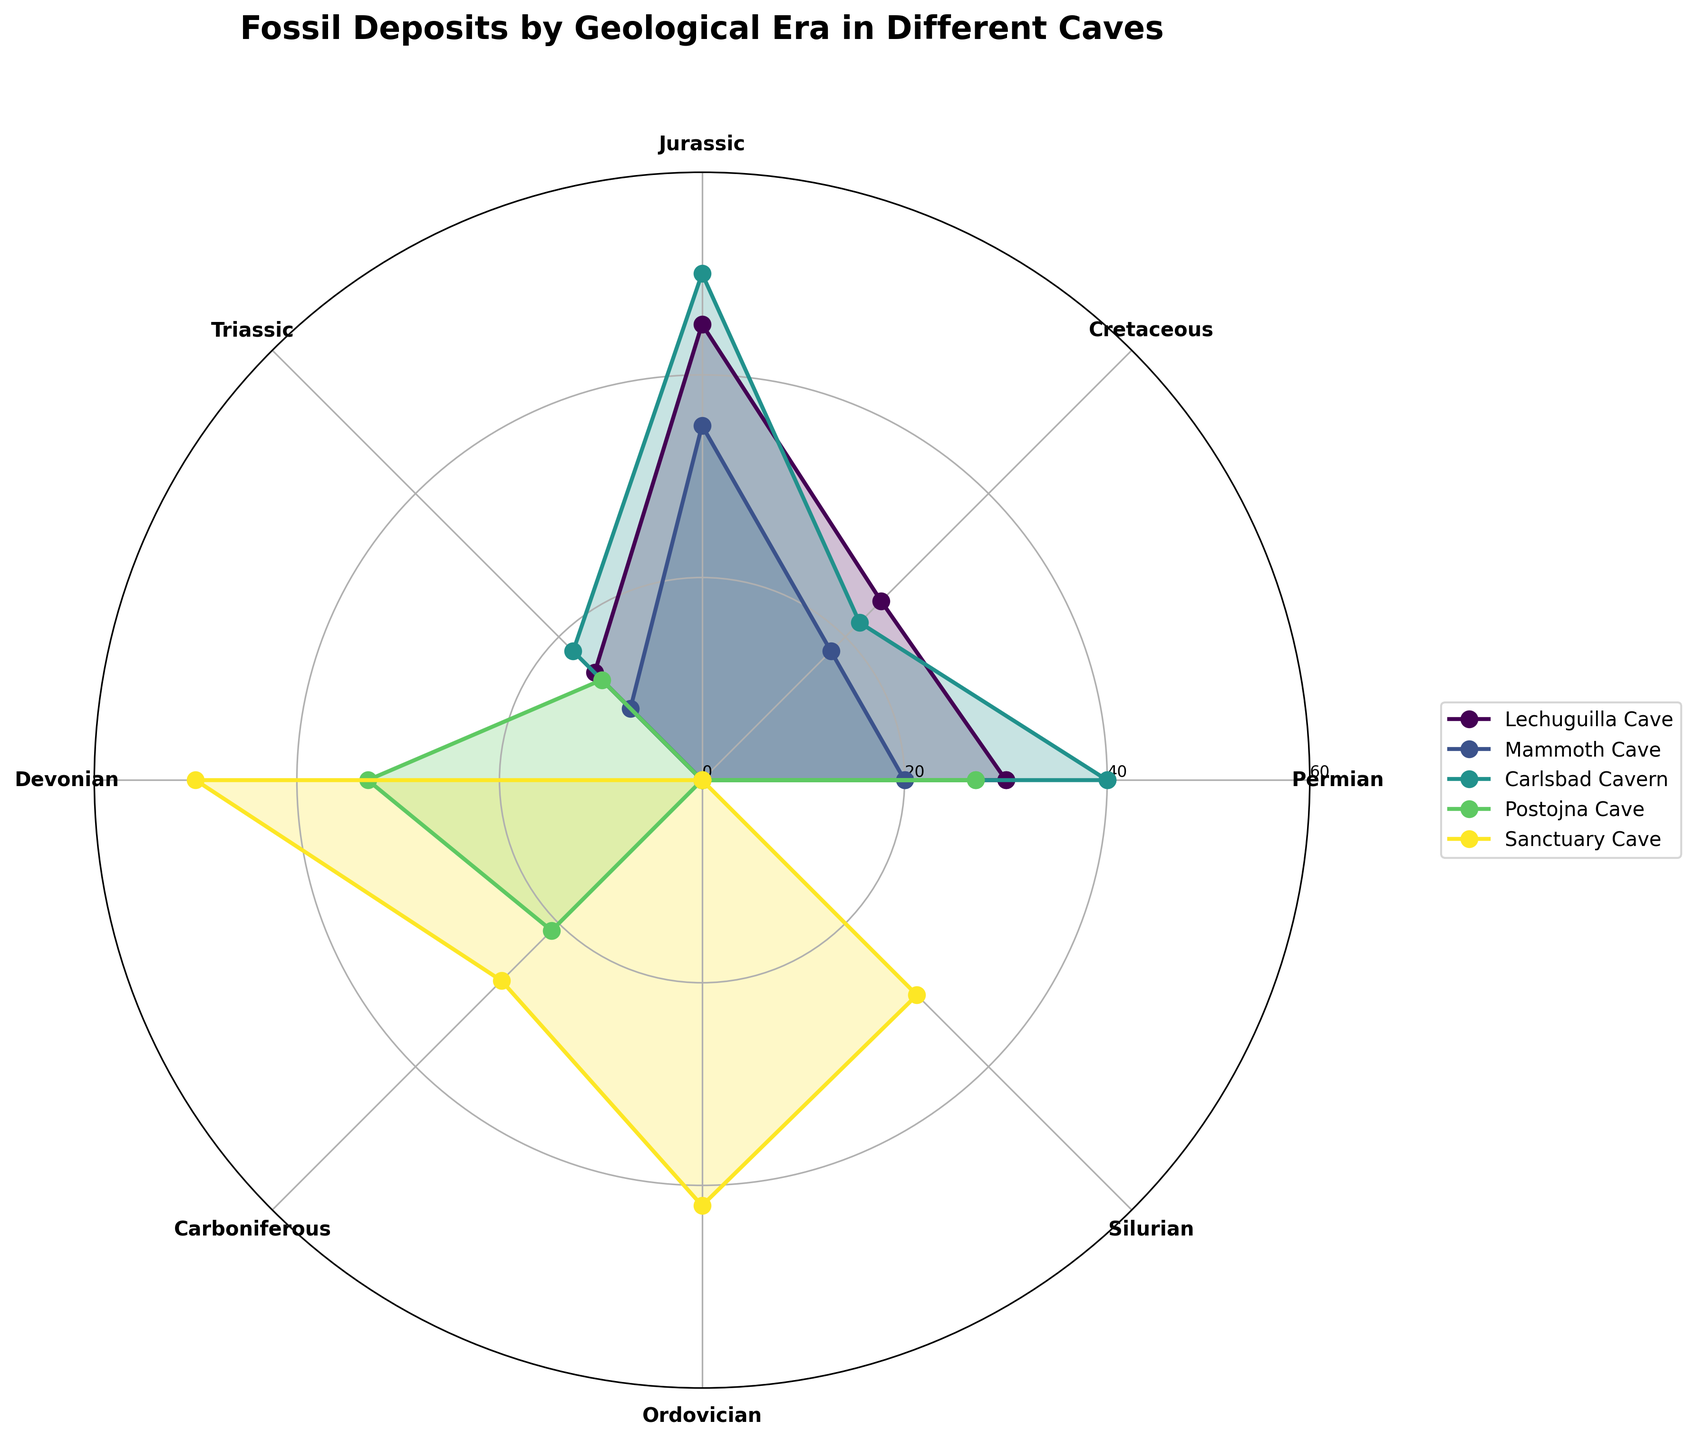Which cave has the highest fossil count in the Jurassic era? Look for the highest value on the polar chart corresponding to the Jurassic era (third position in the legend) and see which cave it belongs to. Carlsbad Cavern is the highest with 50 fossils.
Answer: Carlsbad Cavern Which geological era has the maximum fossil count in Sanctuary Cave? Check the polar plot for Sanctuary Cave and identify the peak value. The highest count is 50 in the Devonian era.
Answer: Devonian Compare the fossil counts of Lechuguilla Cave and Mammoth Cave in the Triassic era. Which cave has more fossils? Compare the values for the Triassic era for both caves. Lechuguilla Cave has 15 fossils, while Mammoth Cave has 10 fossils.
Answer: Lechuguilla Cave What is the total fossil count for Carlsbad Cavern across all geological eras? Sum the fossil counts for Carlsbad Cavern: 40 (Permian) + 22 (Cretaceous) + 50 (Jurassic) + 18 (Triassic) = 130 fossils.
Answer: 130 Which geological era has the least fossil count in all the caves combined? Sum the fossils for each era across all caves and identify the era with the smallest total sum. The Triassic era has the least fossils.
Answer: Triassic Identify the cave with the smallest range of fossil counts across different geological eras. Calculate the range (max - min) of fossil counts for each cave and identify the cave with the smallest range. Mammoth Cave has the smallest range with the values between 10 and 35.
Answer: Mammoth Cave How many more fossils does Postojna Cave have in the Devonian era compared to the Carboniferous era? Look at the values of the Devonian (33) and Carboniferous (21) eras for Postojna Cave, then compute the difference: 33 - 21 = 12.
Answer: 12 Which geological era exhibits the largest variation in fossil counts across all caves? Identify the era with the largest spread between the minimum and maximum fossil counts across all caves, which is achieved by subtracting the smallest count from the largest in each era. The Jurassic era shows the largest variation, ranging from 0 to 50.
Answer: Jurassic Which cave does not have fossil counts for some of the geological eras shown on the plot? Find the cave(s) missing data points (one of their lines doesn't close in the polar area chart). Postojna Cave is missing data for some eras.
Answer: Postojna Cave 